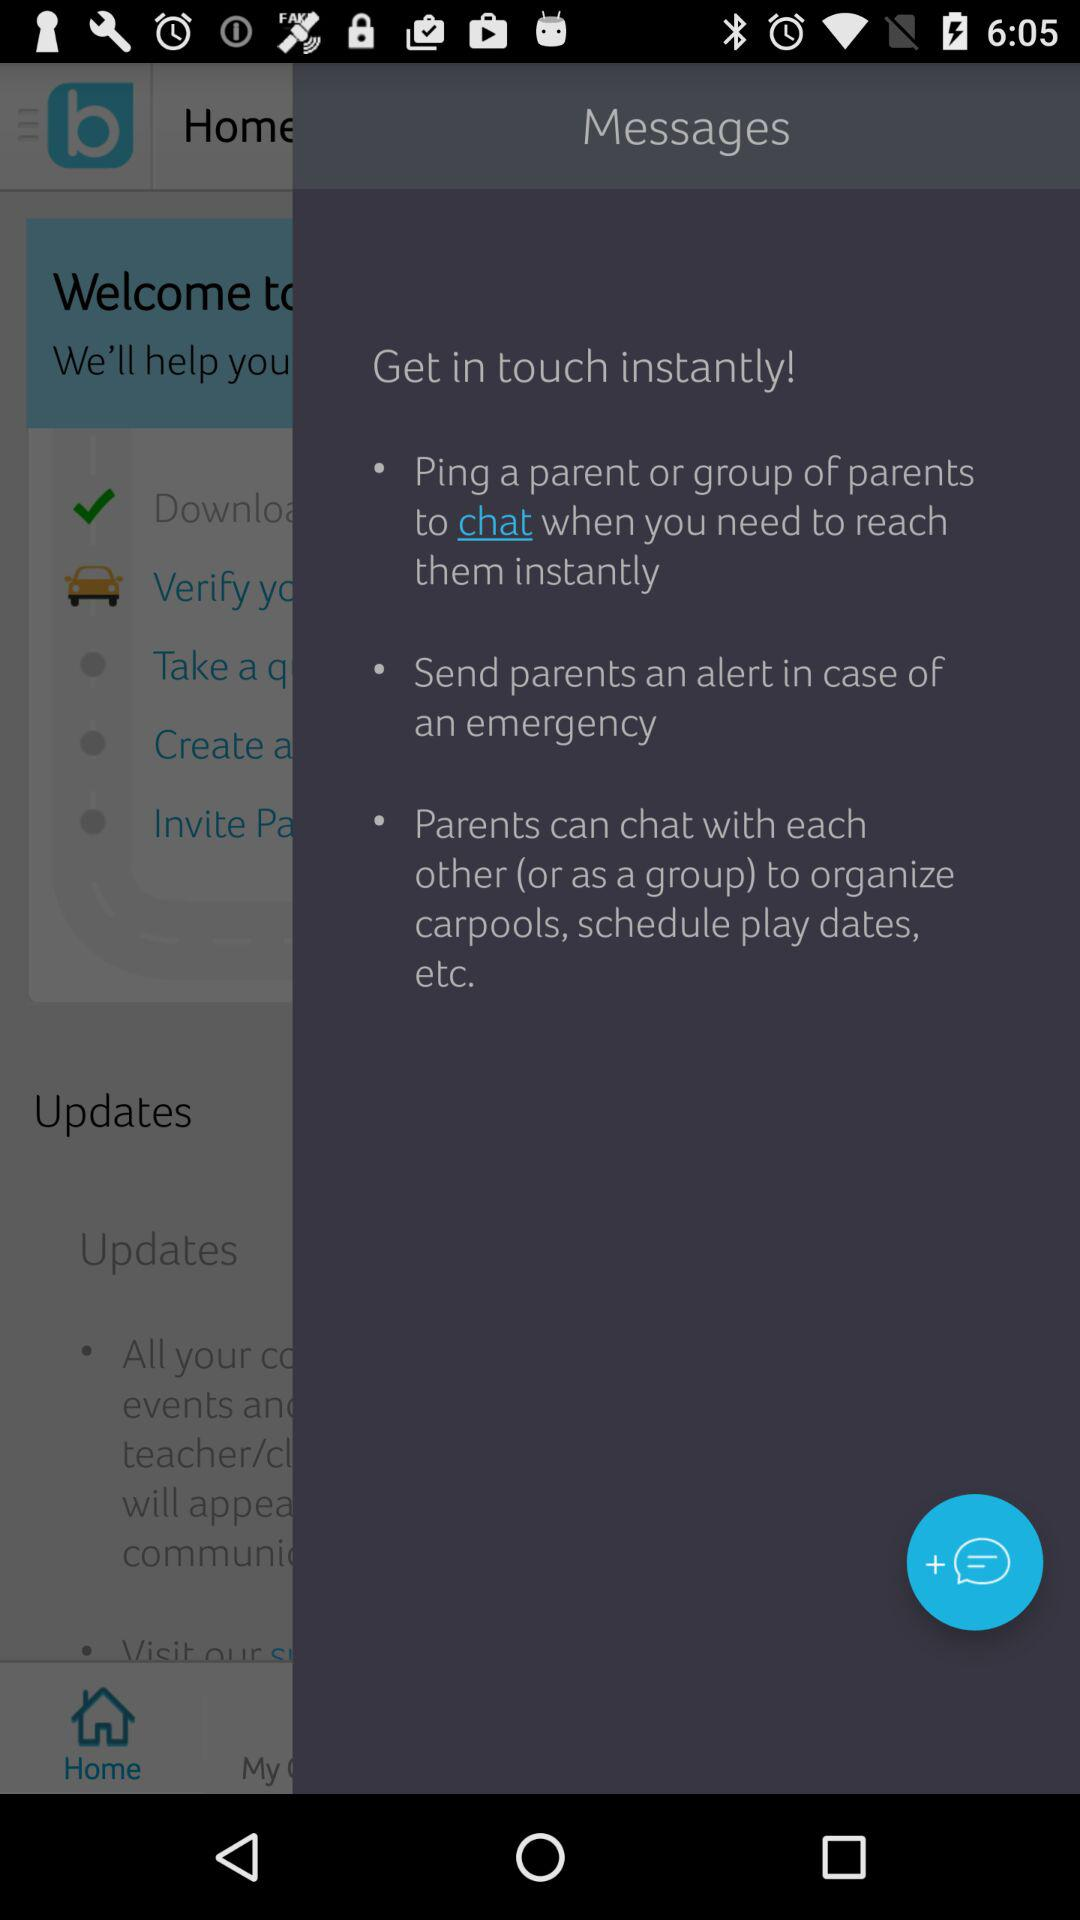Who can chat with each other to organize carpools, schedule play dates, etc.? To organize carpools, schedule play dates, etc., parents can chat with each other. 